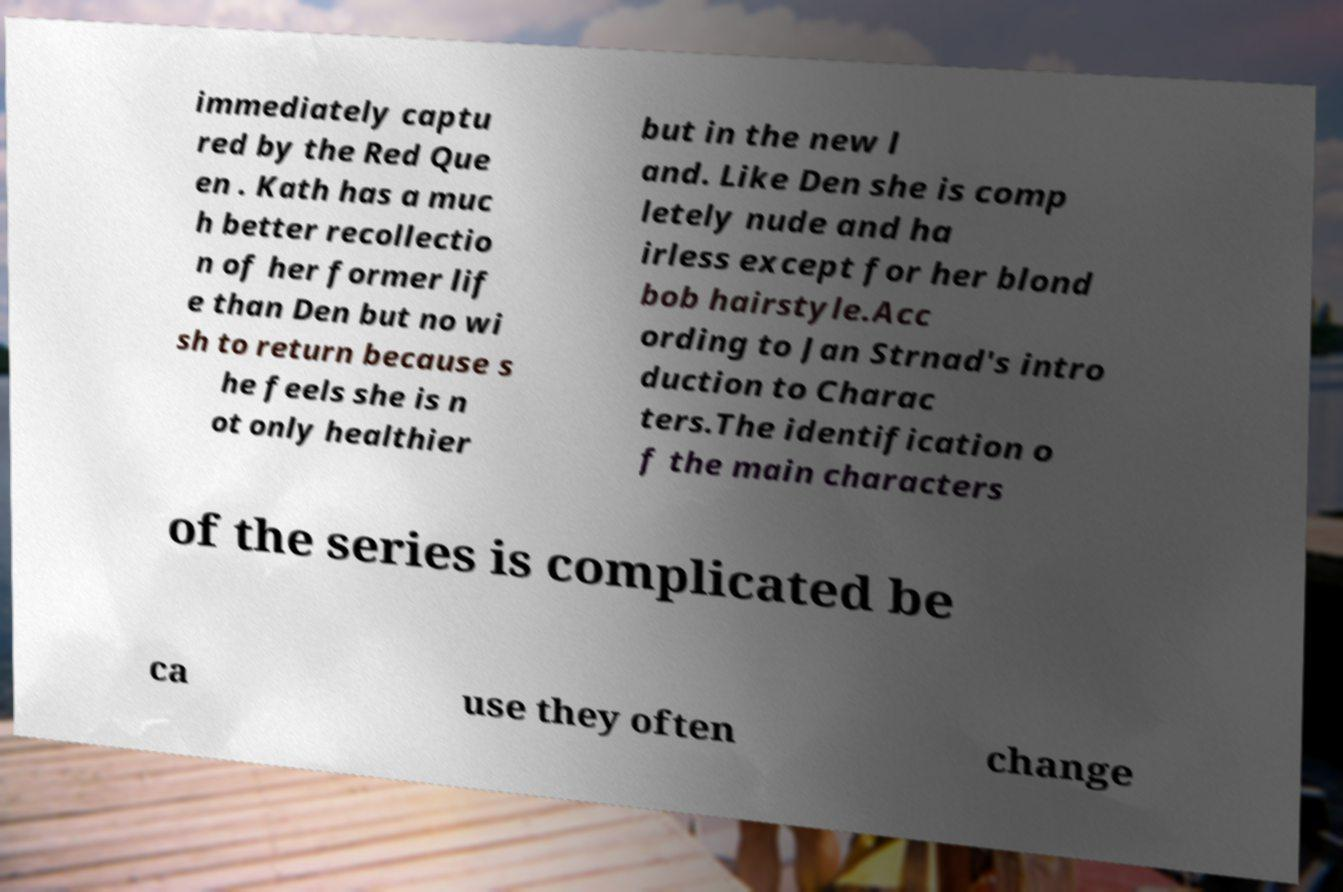For documentation purposes, I need the text within this image transcribed. Could you provide that? immediately captu red by the Red Que en . Kath has a muc h better recollectio n of her former lif e than Den but no wi sh to return because s he feels she is n ot only healthier but in the new l and. Like Den she is comp letely nude and ha irless except for her blond bob hairstyle.Acc ording to Jan Strnad's intro duction to Charac ters.The identification o f the main characters of the series is complicated be ca use they often change 